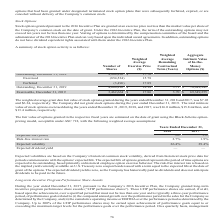According to Aci Worldwide's financial document, What was the expected life (years) in 2018? According to the financial document, 5.6. The relevant text states: "Expected life (years) 5.6 5.6..." Also, What was the risk-free interest rate in 2018? According to the financial document, 2.7%. The relevant text states: "Risk-free interest rate 2.7 % 1.9 %..." Also, What was the risk-free interest rate in 2017? According to the financial document, 1.9%. The relevant text states: "Risk-free interest rate 2.7 % 1.9 %..." Also, can you calculate: What was the change in Expected volatility between 2017 and 2018? Based on the calculation: 26.4%-29.4%, the result is -3 (percentage). This is based on the information: "Expected volatility 26.4 % 29.4 % Expected volatility 26.4 % 29.4 %..." The key data points involved are: 26.4, 29.4. Also, can you calculate: What was the change in risk-free interest rate between 2017 and 2018? Based on the calculation: 2.7%-1.9%, the result is 0.8 (percentage). This is based on the information: "Risk-free interest rate 2.7 % 1.9 % Risk-free interest rate 2.7 % 1.9 %..." The key data points involved are: 1.9, 2.7. Also, can you calculate: What was risk-free interest rate in 2017 as a percentage of risk-free interest rate in 2018? Based on the calculation: 1.9/2.7, the result is 70.37 (percentage). This is based on the information: "Risk-free interest rate 2.7 % 1.9 % Risk-free interest rate 2.7 % 1.9 %..." The key data points involved are: 1.9, 2.7. 